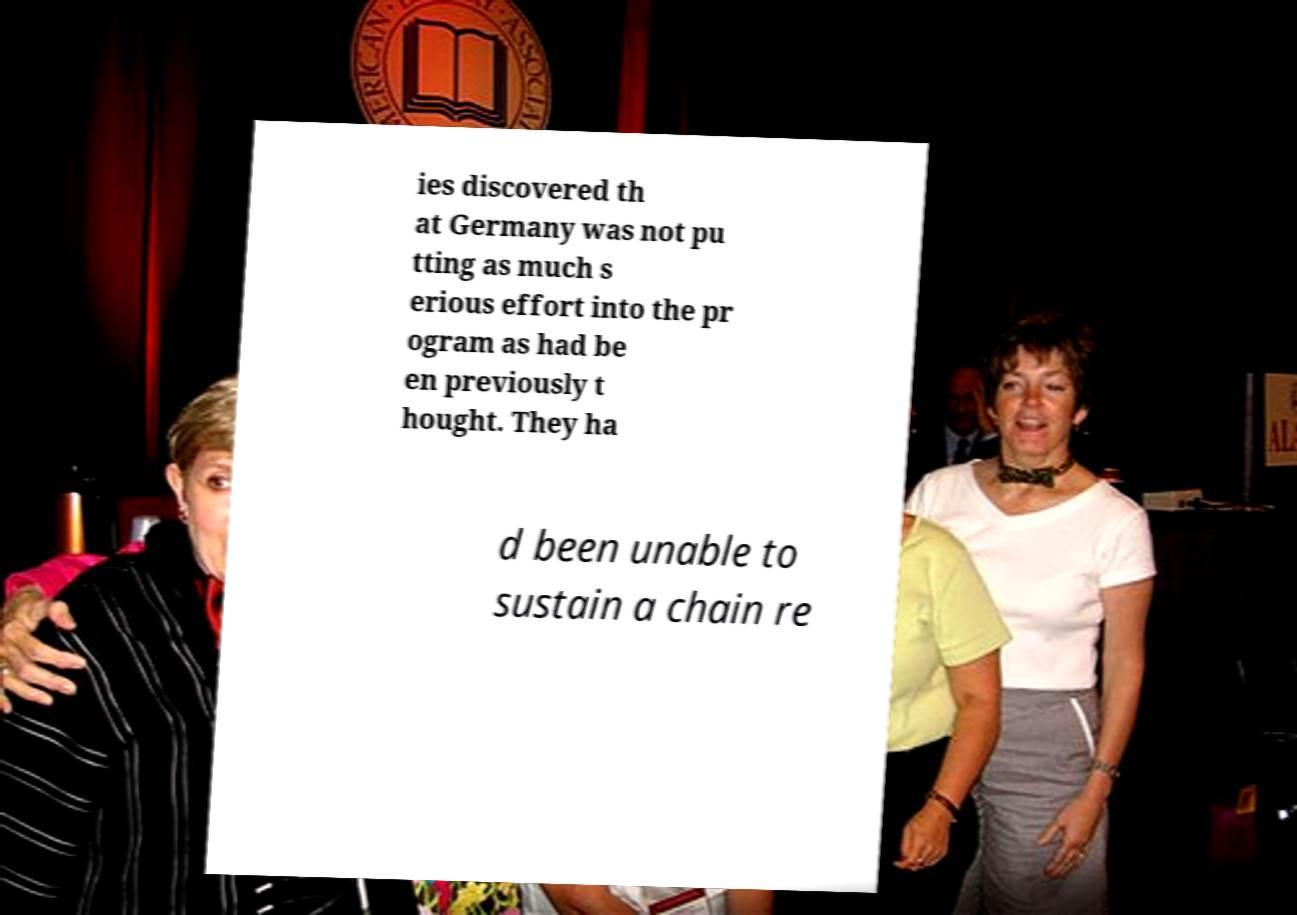Can you read and provide the text displayed in the image?This photo seems to have some interesting text. Can you extract and type it out for me? ies discovered th at Germany was not pu tting as much s erious effort into the pr ogram as had be en previously t hought. They ha d been unable to sustain a chain re 